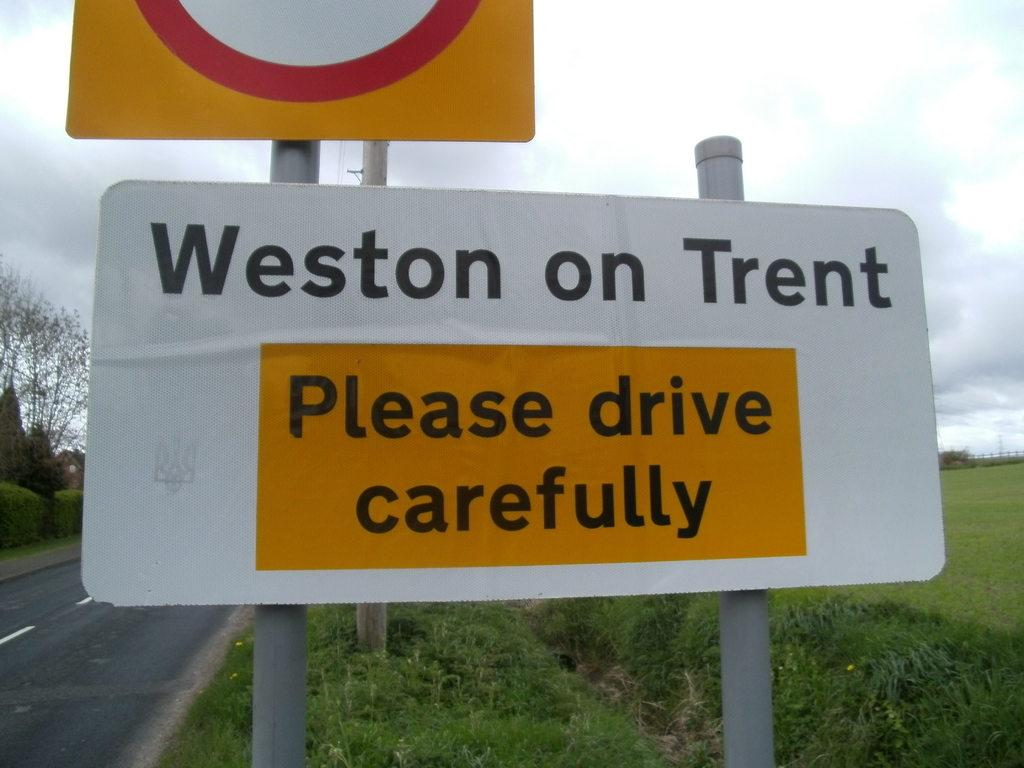Provide a one-sentence caption for the provided image. A sign urging drivers to please drive carefully on Weston on Trent sits on the roadside. 